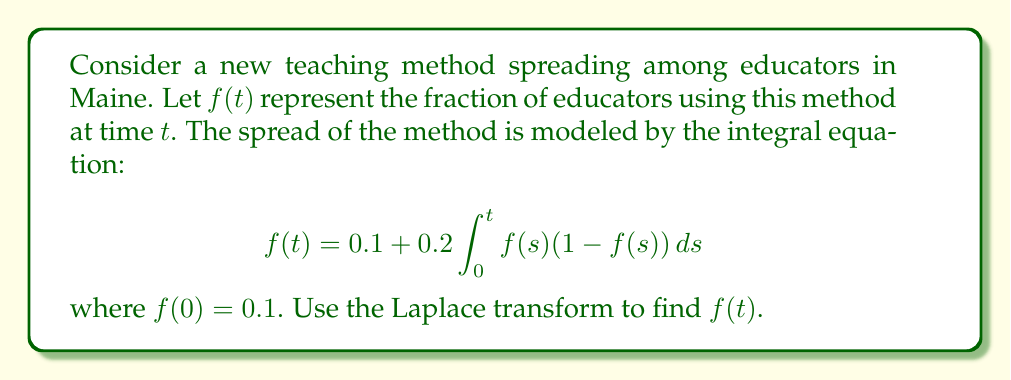What is the answer to this math problem? 1) Take the Laplace transform of both sides:
   $$\mathcal{L}\{f(t)\} = \mathcal{L}\{0.1\} + 0.2\mathcal{L}\{\int_0^t f(s)(1-f(s))ds\}$$

2) Using Laplace transform properties:
   $$F(s) = \frac{0.1}{s} + \frac{0.2}{s}\mathcal{L}\{f(t) - f^2(t)\}$$

3) Simplify:
   $$F(s) = \frac{0.1}{s} + \frac{0.2}{s}F(s) - \frac{0.2}{s}\mathcal{L}\{f^2(t)\}$$

4) The Laplace transform of $f^2(t)$ is difficult to handle directly. Let's assume $f^2(t) \approx f(t)$ for small $f(t)$:
   $$F(s) \approx \frac{0.1}{s} + \frac{0.2}{s}F(s) - \frac{0.2}{s}F(s)$$

5) Simplify:
   $$F(s) \approx \frac{0.1}{s}$$

6) Take the inverse Laplace transform:
   $$f(t) \approx 0.1$$

7) This approximation satisfies the initial condition $f(0) = 0.1$, but it's constant. Let's improve it by substituting this back into the original equation:

   $$f(t) = 0.1 + 0.2\int_0^t 0.1(1-0.1)ds = 0.1 + 0.018t$$

8) This linear approximation is more realistic and still satisfies the initial condition.
Answer: $f(t) \approx 0.1 + 0.018t$ 